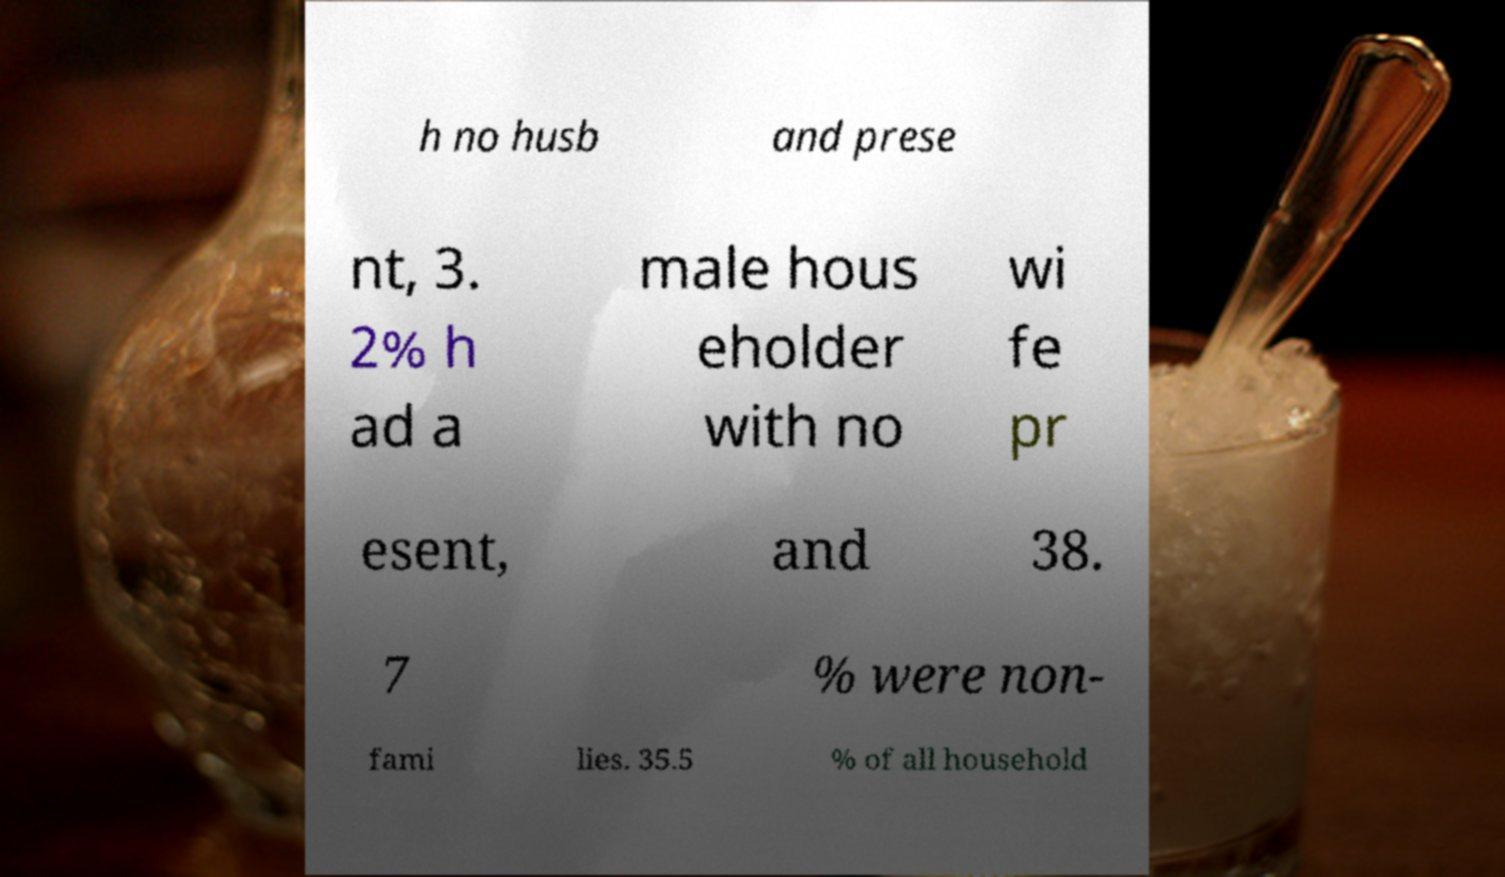Please identify and transcribe the text found in this image. h no husb and prese nt, 3. 2% h ad a male hous eholder with no wi fe pr esent, and 38. 7 % were non- fami lies. 35.5 % of all household 